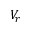<formula> <loc_0><loc_0><loc_500><loc_500>V _ { r }</formula> 